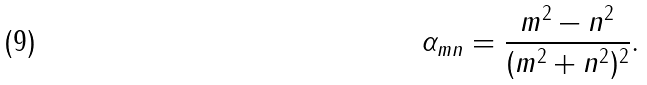Convert formula to latex. <formula><loc_0><loc_0><loc_500><loc_500>\alpha _ { m n } = \frac { m ^ { 2 } - n ^ { 2 } } { ( m ^ { 2 } + n ^ { 2 } ) ^ { 2 } } .</formula> 